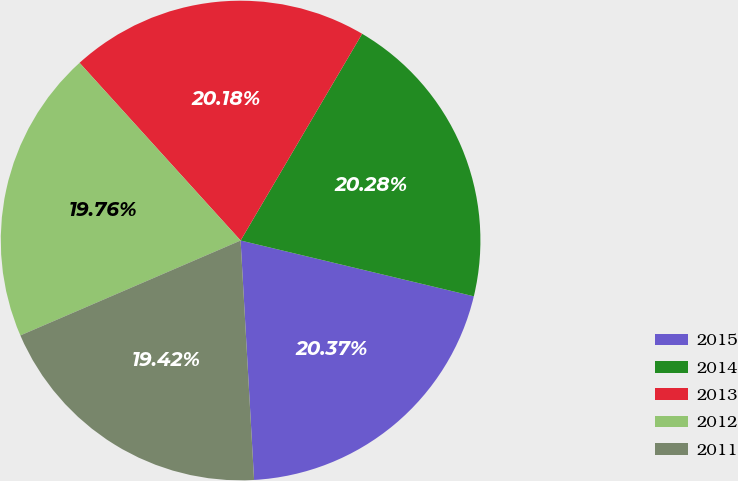Convert chart to OTSL. <chart><loc_0><loc_0><loc_500><loc_500><pie_chart><fcel>2015<fcel>2014<fcel>2013<fcel>2012<fcel>2011<nl><fcel>20.37%<fcel>20.28%<fcel>20.18%<fcel>19.76%<fcel>19.42%<nl></chart> 